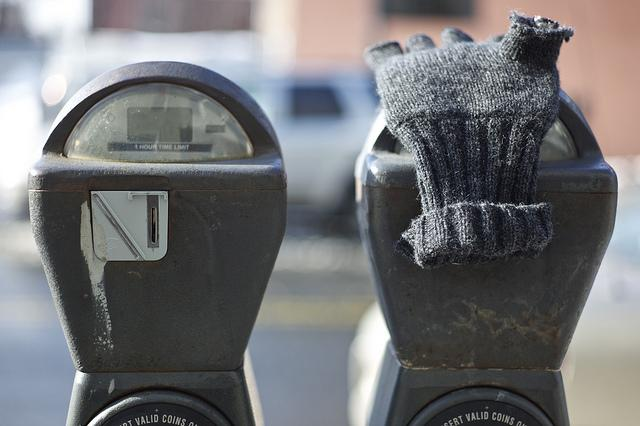What happens if you leave your car parked here an hour and a half? ticket 